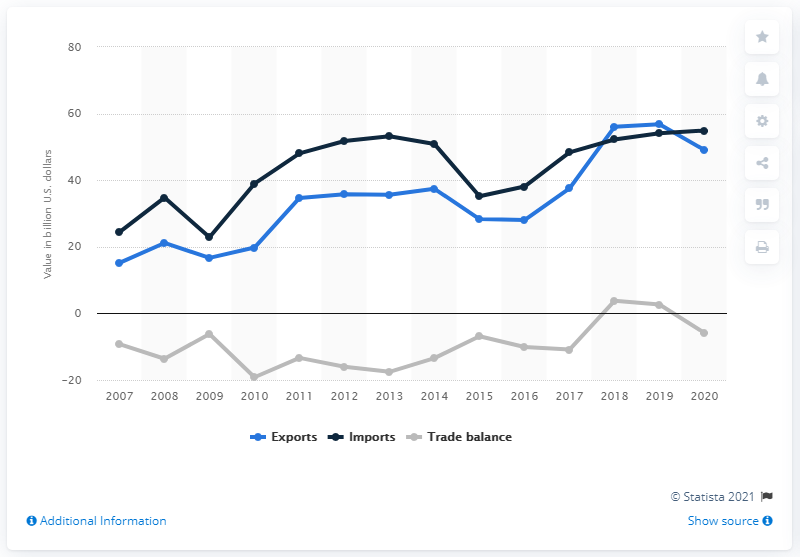Highlight a few significant elements in this photo. In 2020, the value of goods exported from Russia to China in US dollars amounted to approximately $49.06 billion. In 2018, the trade balance of Russia with China was positive for the first time. In 2020, the value of Russian merchandise imports into China was 54.13 billion Russian rubles. 